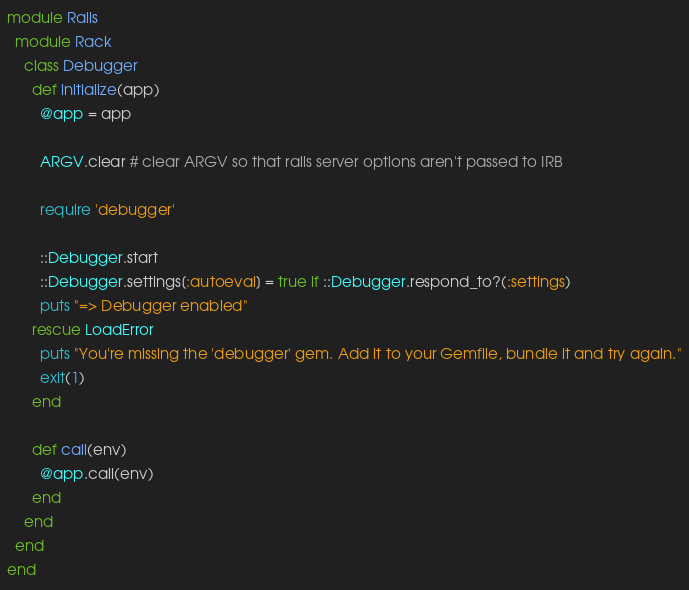Convert code to text. <code><loc_0><loc_0><loc_500><loc_500><_Ruby_>module Rails
  module Rack
    class Debugger
      def initialize(app)
        @app = app

        ARGV.clear # clear ARGV so that rails server options aren't passed to IRB

        require 'debugger'

        ::Debugger.start
        ::Debugger.settings[:autoeval] = true if ::Debugger.respond_to?(:settings)
        puts "=> Debugger enabled"
      rescue LoadError
        puts "You're missing the 'debugger' gem. Add it to your Gemfile, bundle it and try again."
        exit(1)
      end

      def call(env)
        @app.call(env)
      end
    end
  end
end
</code> 